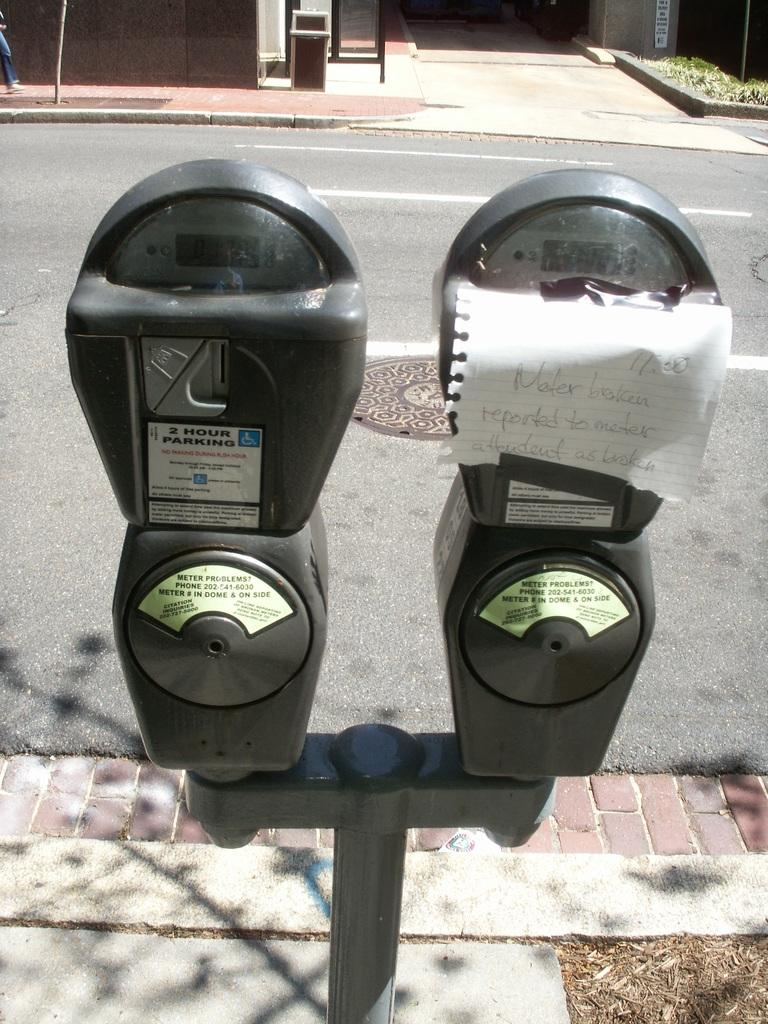Provide a one-sentence caption for the provided image. A broken meter, and paper that says Meter broken reported to meter attentant as broken. 